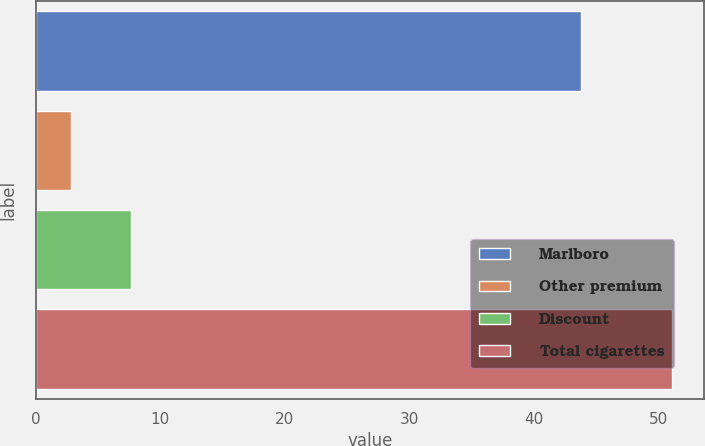Convert chart to OTSL. <chart><loc_0><loc_0><loc_500><loc_500><bar_chart><fcel>Marlboro<fcel>Other premium<fcel>Discount<fcel>Total cigarettes<nl><fcel>43.8<fcel>2.8<fcel>7.63<fcel>51.1<nl></chart> 